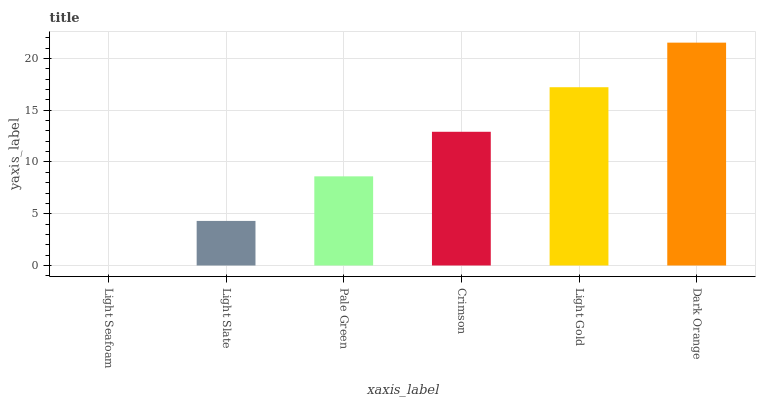Is Light Slate the minimum?
Answer yes or no. No. Is Light Slate the maximum?
Answer yes or no. No. Is Light Slate greater than Light Seafoam?
Answer yes or no. Yes. Is Light Seafoam less than Light Slate?
Answer yes or no. Yes. Is Light Seafoam greater than Light Slate?
Answer yes or no. No. Is Light Slate less than Light Seafoam?
Answer yes or no. No. Is Crimson the high median?
Answer yes or no. Yes. Is Pale Green the low median?
Answer yes or no. Yes. Is Light Slate the high median?
Answer yes or no. No. Is Light Seafoam the low median?
Answer yes or no. No. 